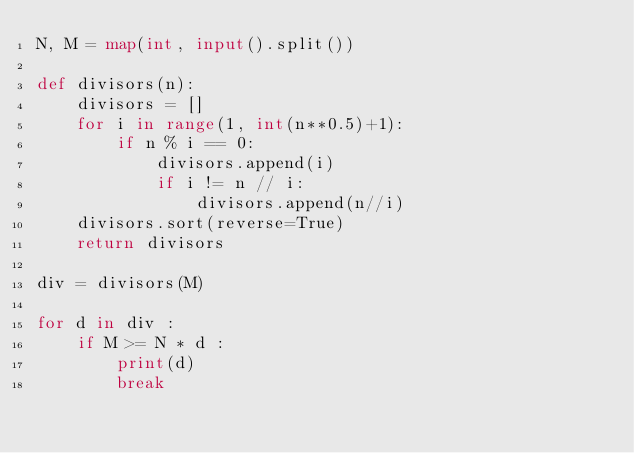<code> <loc_0><loc_0><loc_500><loc_500><_Python_>N, M = map(int, input().split())

def divisors(n):
    divisors = []
    for i in range(1, int(n**0.5)+1):
        if n % i == 0:
            divisors.append(i)
            if i != n // i:
                divisors.append(n//i)
    divisors.sort(reverse=True)
    return divisors

div = divisors(M)

for d in div :
    if M >= N * d :
        print(d)
        break


</code> 